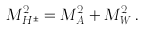<formula> <loc_0><loc_0><loc_500><loc_500>M _ { H ^ { \pm } } ^ { 2 } = M _ { A } ^ { 2 } + M _ { W } ^ { 2 } \, .</formula> 